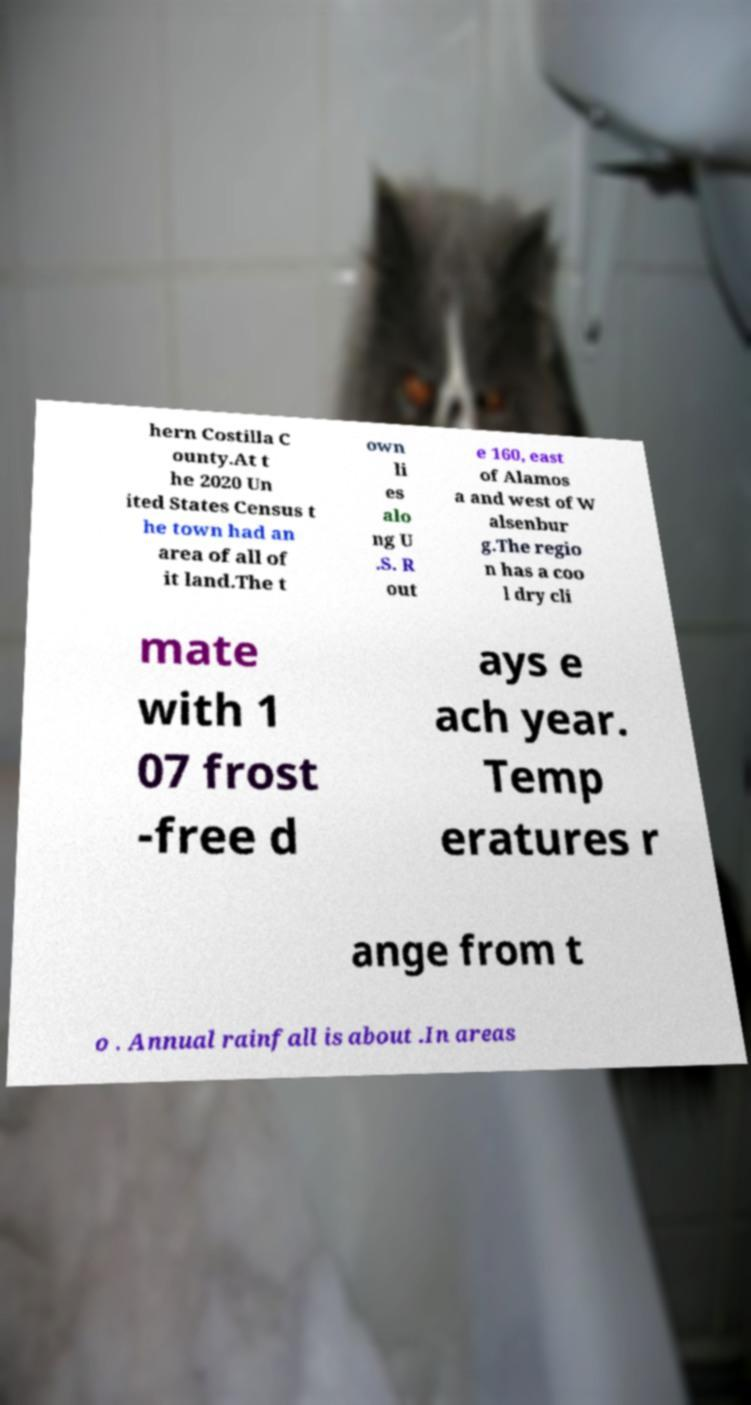I need the written content from this picture converted into text. Can you do that? hern Costilla C ounty.At t he 2020 Un ited States Census t he town had an area of all of it land.The t own li es alo ng U .S. R out e 160, east of Alamos a and west of W alsenbur g.The regio n has a coo l dry cli mate with 1 07 frost -free d ays e ach year. Temp eratures r ange from t o . Annual rainfall is about .In areas 